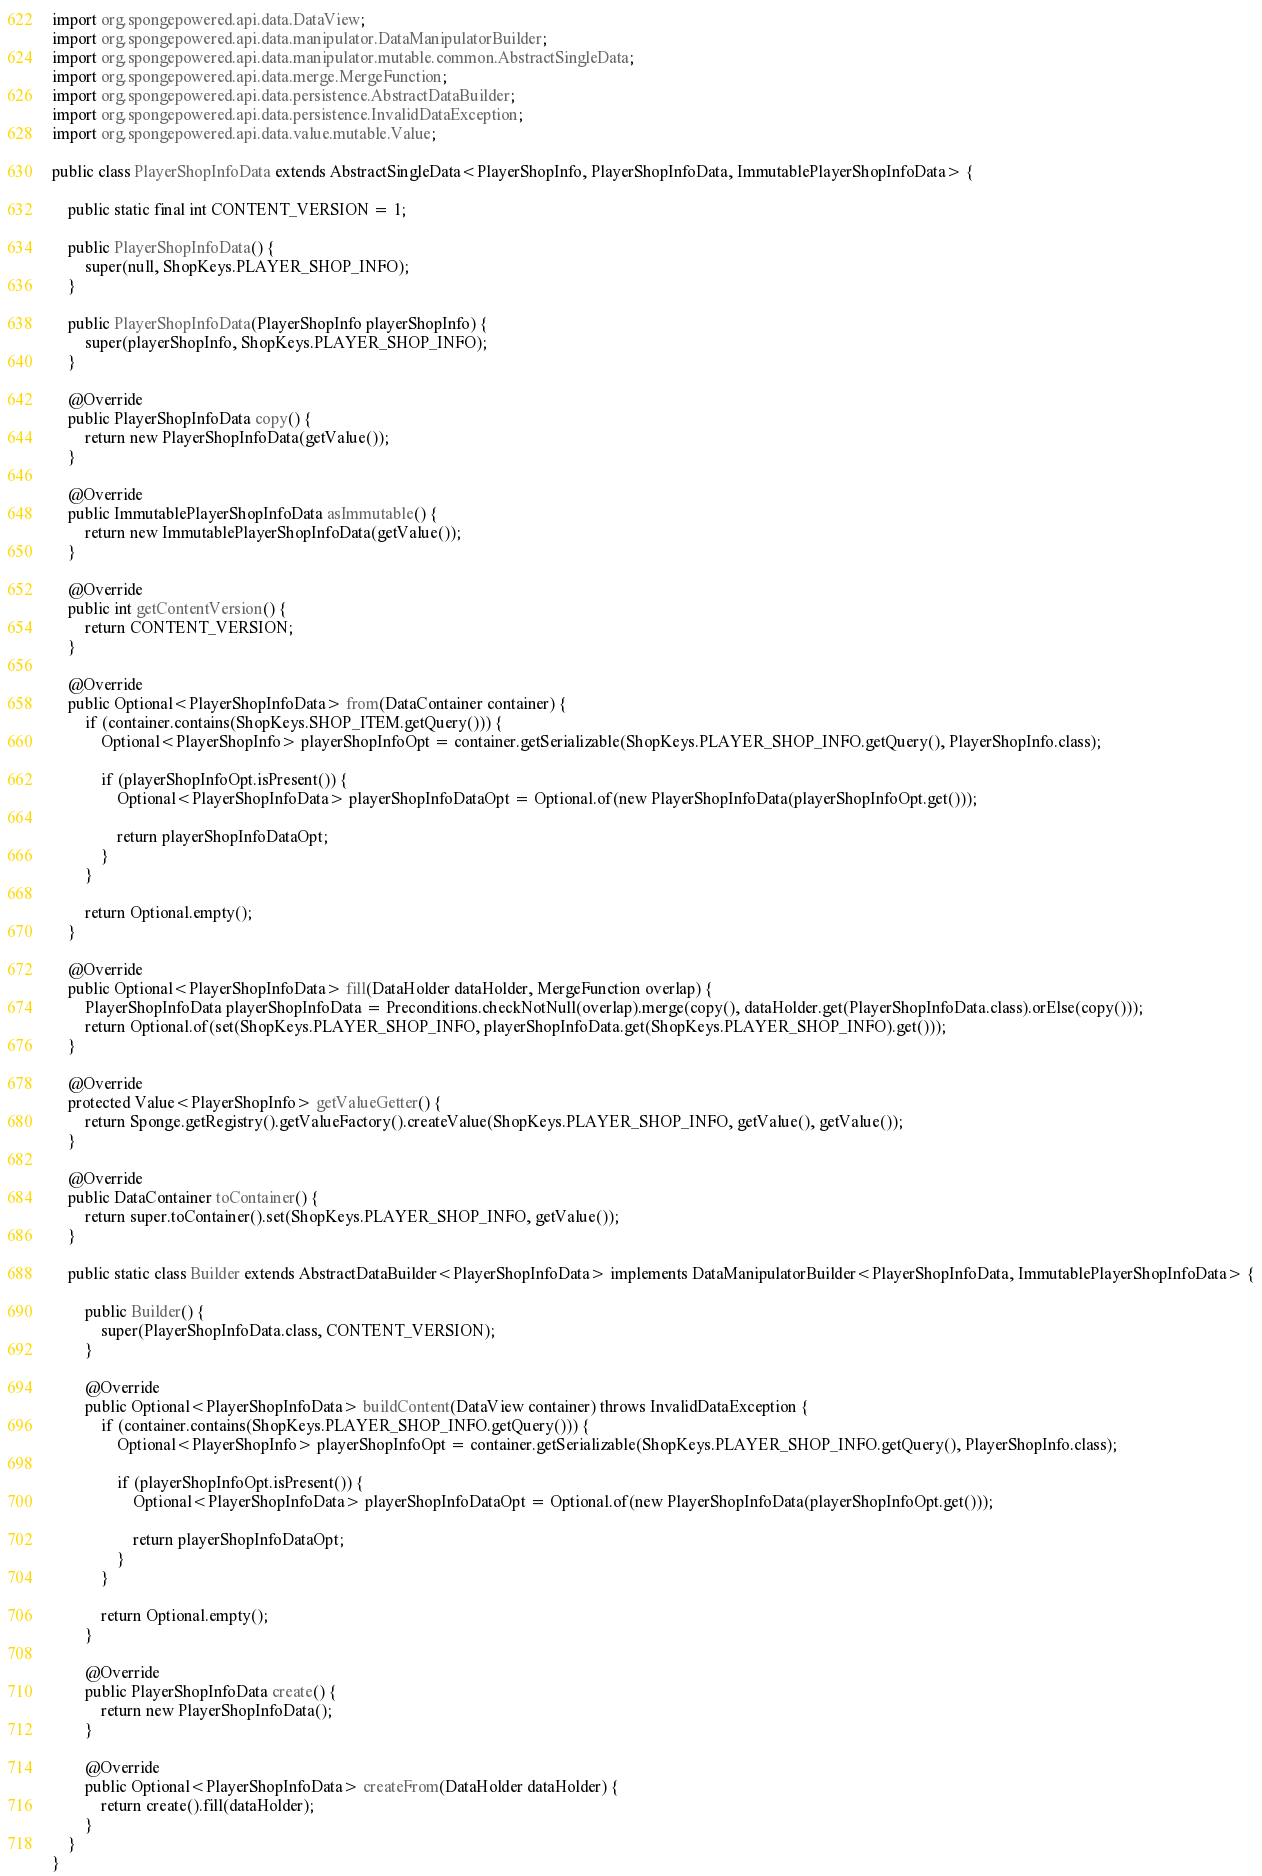<code> <loc_0><loc_0><loc_500><loc_500><_Java_>import org.spongepowered.api.data.DataView;
import org.spongepowered.api.data.manipulator.DataManipulatorBuilder;
import org.spongepowered.api.data.manipulator.mutable.common.AbstractSingleData;
import org.spongepowered.api.data.merge.MergeFunction;
import org.spongepowered.api.data.persistence.AbstractDataBuilder;
import org.spongepowered.api.data.persistence.InvalidDataException;
import org.spongepowered.api.data.value.mutable.Value;

public class PlayerShopInfoData extends AbstractSingleData<PlayerShopInfo, PlayerShopInfoData, ImmutablePlayerShopInfoData> {

    public static final int CONTENT_VERSION = 1;

    public PlayerShopInfoData() {
        super(null, ShopKeys.PLAYER_SHOP_INFO);
    }

    public PlayerShopInfoData(PlayerShopInfo playerShopInfo) {
        super(playerShopInfo, ShopKeys.PLAYER_SHOP_INFO);
    }

    @Override
    public PlayerShopInfoData copy() {
        return new PlayerShopInfoData(getValue());
    }

    @Override
    public ImmutablePlayerShopInfoData asImmutable() {
        return new ImmutablePlayerShopInfoData(getValue());
    }

    @Override
    public int getContentVersion() {
        return CONTENT_VERSION;
    }

    @Override
    public Optional<PlayerShopInfoData> from(DataContainer container) {
        if (container.contains(ShopKeys.SHOP_ITEM.getQuery())) {
            Optional<PlayerShopInfo> playerShopInfoOpt = container.getSerializable(ShopKeys.PLAYER_SHOP_INFO.getQuery(), PlayerShopInfo.class);

            if (playerShopInfoOpt.isPresent()) {
                Optional<PlayerShopInfoData> playerShopInfoDataOpt = Optional.of(new PlayerShopInfoData(playerShopInfoOpt.get()));

                return playerShopInfoDataOpt;
            }
        }

        return Optional.empty();
    }

    @Override
    public Optional<PlayerShopInfoData> fill(DataHolder dataHolder, MergeFunction overlap) {
        PlayerShopInfoData playerShopInfoData = Preconditions.checkNotNull(overlap).merge(copy(), dataHolder.get(PlayerShopInfoData.class).orElse(copy()));
        return Optional.of(set(ShopKeys.PLAYER_SHOP_INFO, playerShopInfoData.get(ShopKeys.PLAYER_SHOP_INFO).get()));
    }

    @Override
    protected Value<PlayerShopInfo> getValueGetter() {
        return Sponge.getRegistry().getValueFactory().createValue(ShopKeys.PLAYER_SHOP_INFO, getValue(), getValue());
    }

    @Override
    public DataContainer toContainer() {
        return super.toContainer().set(ShopKeys.PLAYER_SHOP_INFO, getValue());
    }

    public static class Builder extends AbstractDataBuilder<PlayerShopInfoData> implements DataManipulatorBuilder<PlayerShopInfoData, ImmutablePlayerShopInfoData> {

        public Builder() {
            super(PlayerShopInfoData.class, CONTENT_VERSION);
        }

        @Override
        public Optional<PlayerShopInfoData> buildContent(DataView container) throws InvalidDataException {
            if (container.contains(ShopKeys.PLAYER_SHOP_INFO.getQuery())) {
                Optional<PlayerShopInfo> playerShopInfoOpt = container.getSerializable(ShopKeys.PLAYER_SHOP_INFO.getQuery(), PlayerShopInfo.class);

                if (playerShopInfoOpt.isPresent()) {
                    Optional<PlayerShopInfoData> playerShopInfoDataOpt = Optional.of(new PlayerShopInfoData(playerShopInfoOpt.get()));

                    return playerShopInfoDataOpt;
                }
            }

            return Optional.empty();
        }

        @Override
        public PlayerShopInfoData create() {
            return new PlayerShopInfoData();
        }

        @Override
        public Optional<PlayerShopInfoData> createFrom(DataHolder dataHolder) {
            return create().fill(dataHolder);
        }
    }
}
</code> 